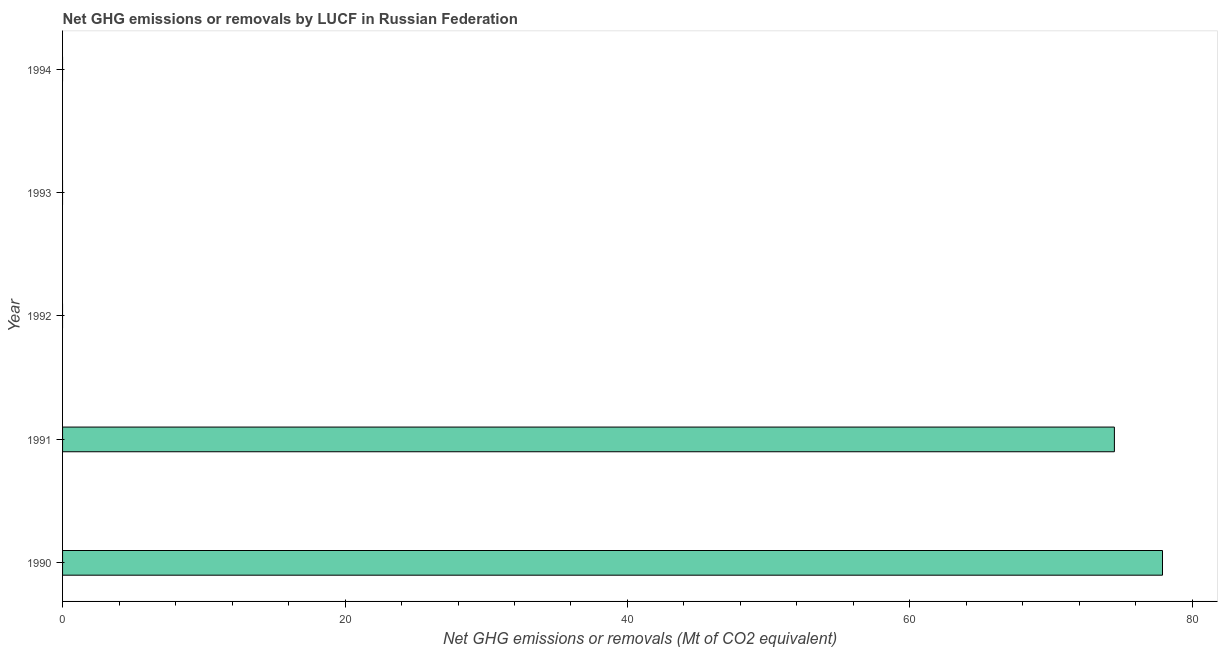Does the graph contain any zero values?
Give a very brief answer. Yes. Does the graph contain grids?
Provide a short and direct response. No. What is the title of the graph?
Give a very brief answer. Net GHG emissions or removals by LUCF in Russian Federation. What is the label or title of the X-axis?
Give a very brief answer. Net GHG emissions or removals (Mt of CO2 equivalent). What is the label or title of the Y-axis?
Keep it short and to the point. Year. What is the ghg net emissions or removals in 1994?
Provide a succinct answer. 0. Across all years, what is the maximum ghg net emissions or removals?
Provide a succinct answer. 77.88. Across all years, what is the minimum ghg net emissions or removals?
Provide a succinct answer. 0. In which year was the ghg net emissions or removals maximum?
Your answer should be very brief. 1990. What is the sum of the ghg net emissions or removals?
Offer a terse response. 152.36. What is the difference between the ghg net emissions or removals in 1990 and 1991?
Provide a short and direct response. 3.41. What is the average ghg net emissions or removals per year?
Offer a terse response. 30.47. What is the ratio of the ghg net emissions or removals in 1990 to that in 1991?
Provide a succinct answer. 1.05. What is the difference between the highest and the lowest ghg net emissions or removals?
Offer a very short reply. 77.88. In how many years, is the ghg net emissions or removals greater than the average ghg net emissions or removals taken over all years?
Provide a succinct answer. 2. How many bars are there?
Make the answer very short. 2. Are all the bars in the graph horizontal?
Provide a succinct answer. Yes. How many years are there in the graph?
Provide a short and direct response. 5. What is the Net GHG emissions or removals (Mt of CO2 equivalent) of 1990?
Keep it short and to the point. 77.88. What is the Net GHG emissions or removals (Mt of CO2 equivalent) in 1991?
Your answer should be very brief. 74.48. What is the difference between the Net GHG emissions or removals (Mt of CO2 equivalent) in 1990 and 1991?
Your response must be concise. 3.41. What is the ratio of the Net GHG emissions or removals (Mt of CO2 equivalent) in 1990 to that in 1991?
Keep it short and to the point. 1.05. 